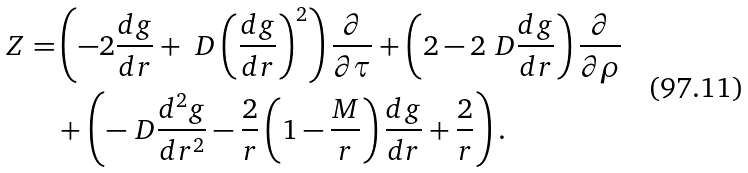Convert formula to latex. <formula><loc_0><loc_0><loc_500><loc_500>Z = & \left ( - 2 \frac { d g } { d r } + \ D \left ( \frac { d g } { d r } \right ) ^ { 2 } \right ) \frac { \partial } { \partial \tau } + \left ( 2 - 2 \ D \frac { d g } { d r } \right ) \frac { \partial } { \partial \rho } \\ & + \left ( - \ D \frac { d ^ { 2 } g } { d r ^ { 2 } } - \frac { 2 } { r } \left ( 1 - \frac { M } { r } \right ) \frac { d g } { d r } + \frac { 2 } { r } \right ) .</formula> 